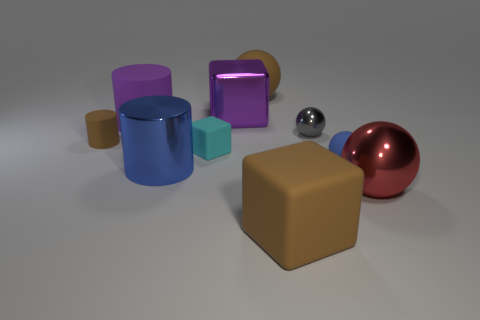Subtract 1 balls. How many balls are left? 3 Subtract all blocks. How many objects are left? 7 Subtract 0 cyan cylinders. How many objects are left? 10 Subtract all brown rubber cylinders. Subtract all blue rubber balls. How many objects are left? 8 Add 7 small blue objects. How many small blue objects are left? 8 Add 2 red rubber objects. How many red rubber objects exist? 2 